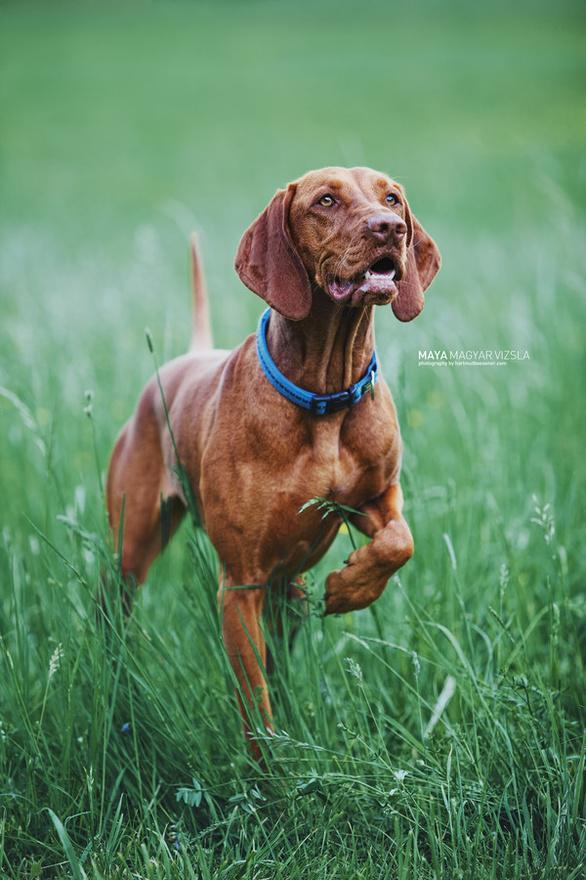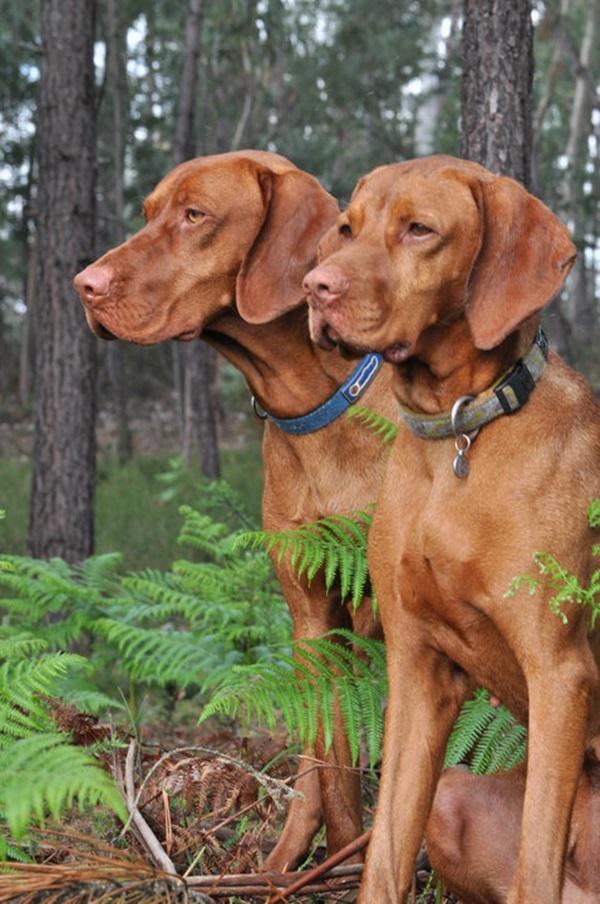The first image is the image on the left, the second image is the image on the right. Considering the images on both sides, is "One dog's teeth are visible." valid? Answer yes or no. Yes. The first image is the image on the left, the second image is the image on the right. For the images shown, is this caption "A total of three red-orange dogs, all wearing collars, are shown - and the right image contains two side-by-side dogs gazing in the same direction." true? Answer yes or no. Yes. 